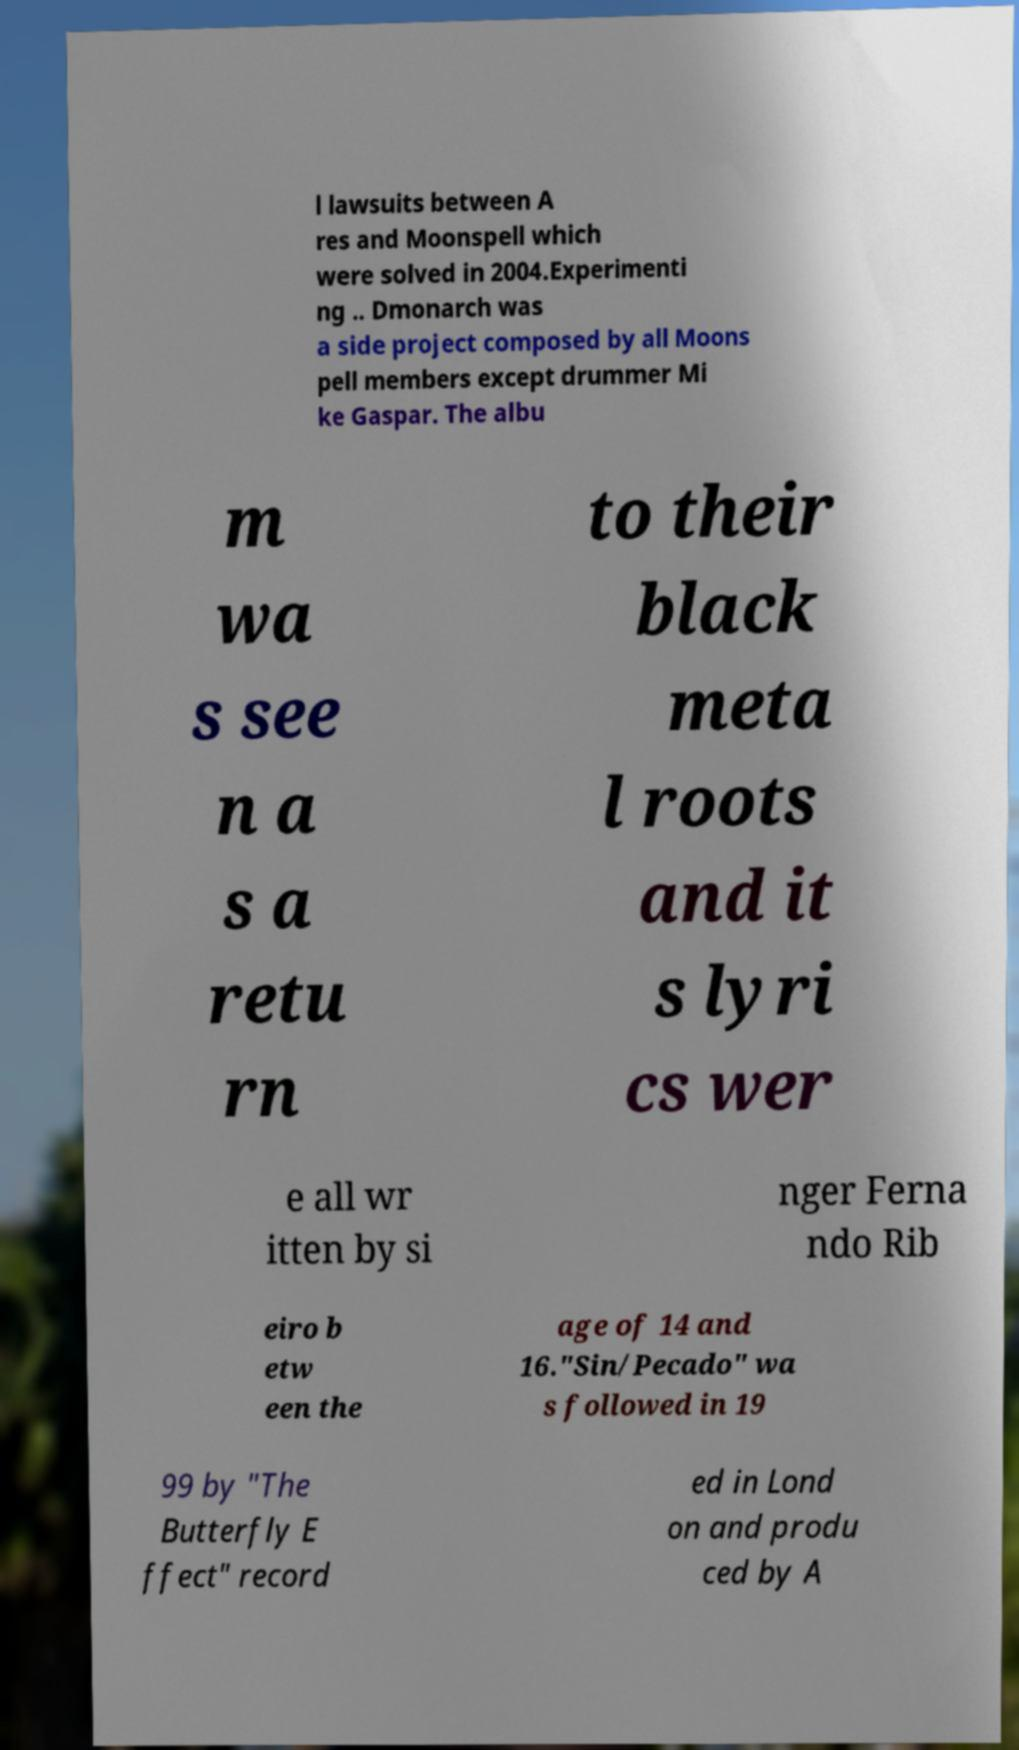Please read and relay the text visible in this image. What does it say? l lawsuits between A res and Moonspell which were solved in 2004.Experimenti ng .. Dmonarch was a side project composed by all Moons pell members except drummer Mi ke Gaspar. The albu m wa s see n a s a retu rn to their black meta l roots and it s lyri cs wer e all wr itten by si nger Ferna ndo Rib eiro b etw een the age of 14 and 16."Sin/Pecado" wa s followed in 19 99 by "The Butterfly E ffect" record ed in Lond on and produ ced by A 